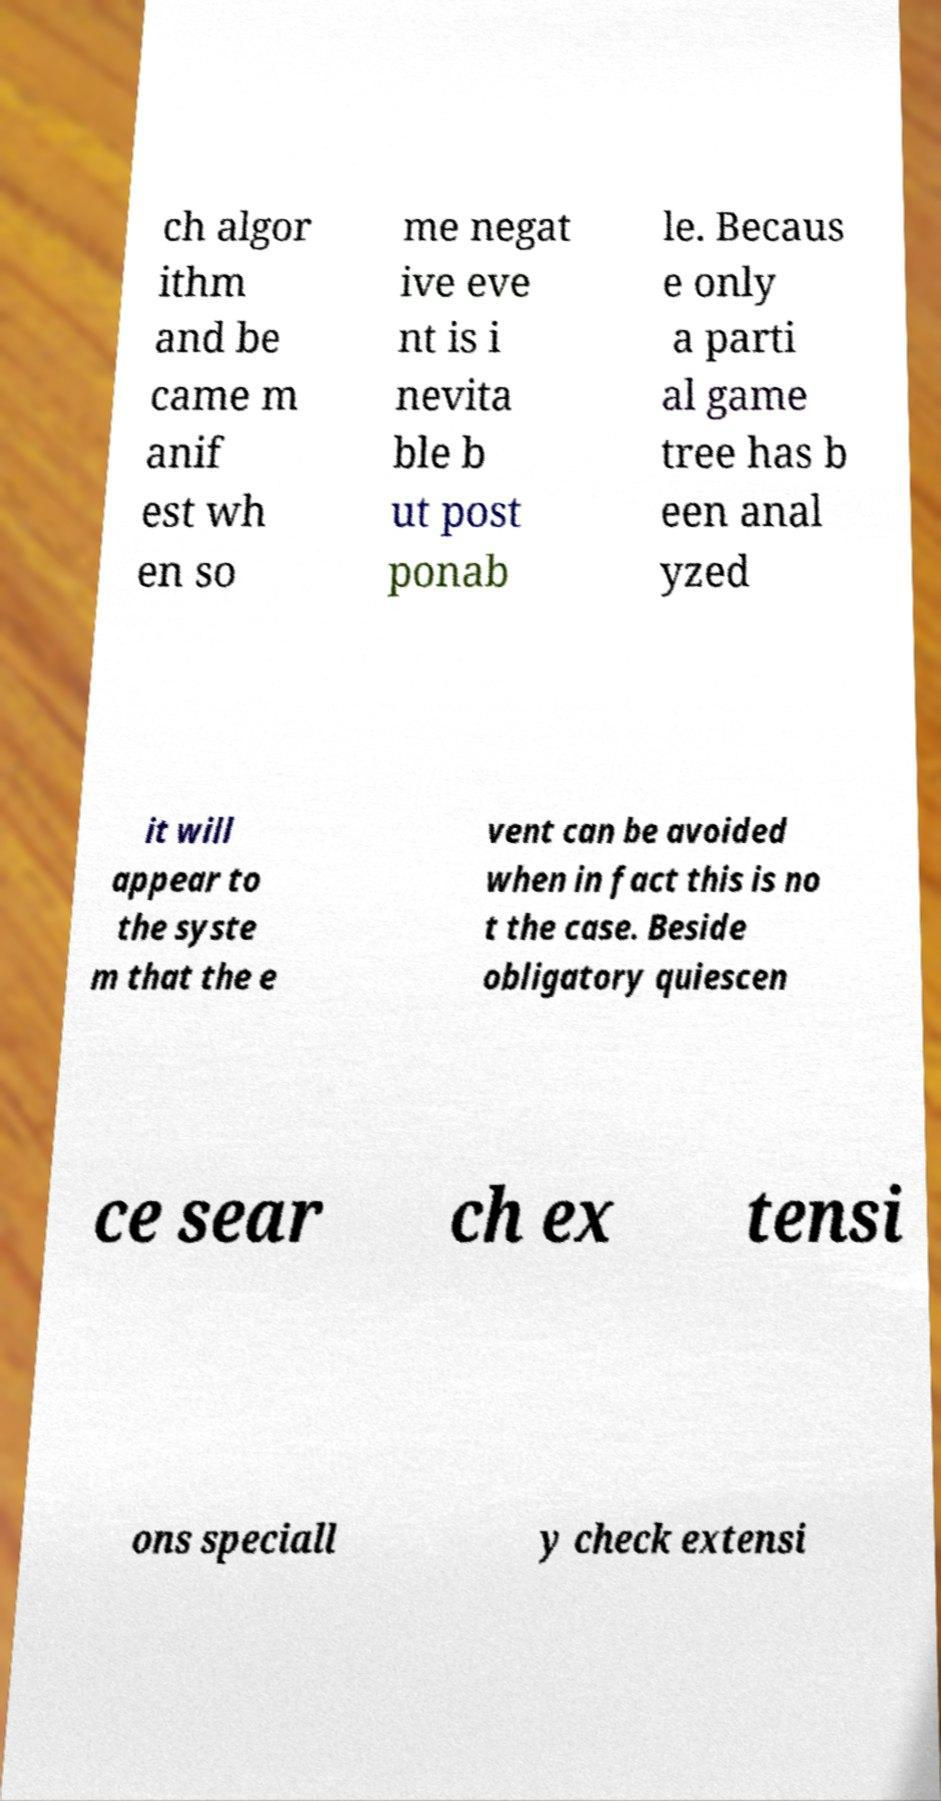I need the written content from this picture converted into text. Can you do that? ch algor ithm and be came m anif est wh en so me negat ive eve nt is i nevita ble b ut post ponab le. Becaus e only a parti al game tree has b een anal yzed it will appear to the syste m that the e vent can be avoided when in fact this is no t the case. Beside obligatory quiescen ce sear ch ex tensi ons speciall y check extensi 